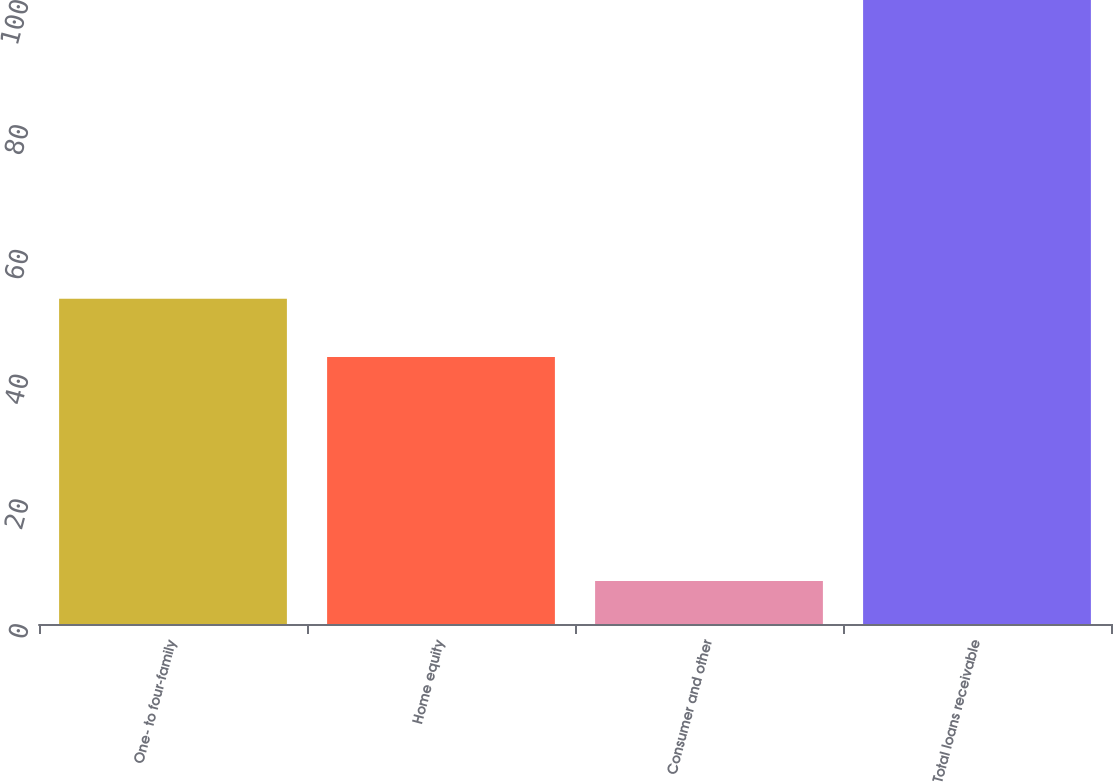Convert chart. <chart><loc_0><loc_0><loc_500><loc_500><bar_chart><fcel>One- to four-family<fcel>Home equity<fcel>Consumer and other<fcel>Total loans receivable<nl><fcel>52.11<fcel>42.8<fcel>6.9<fcel>100<nl></chart> 